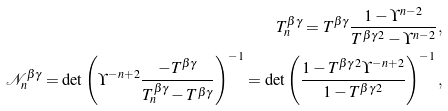<formula> <loc_0><loc_0><loc_500><loc_500>T ^ { \beta \gamma } _ { n } = T ^ { \beta \gamma } \frac { 1 - \Upsilon ^ { n - 2 } } { T ^ { \beta \gamma \, 2 } - \Upsilon ^ { n - 2 } } , \\ \mathcal { N } ^ { \beta \gamma } _ { n } = \det \left ( \Upsilon ^ { - n + 2 } \frac { - T ^ { \beta \gamma } } { T ^ { \beta \gamma } _ { n } - T ^ { \beta \gamma } } \right ) ^ { - 1 } = \det \left ( \frac { 1 - T ^ { \beta \gamma \, 2 } \Upsilon ^ { - n + 2 } } { 1 - T ^ { \beta \gamma \, 2 } } \right ) ^ { - 1 } ,</formula> 